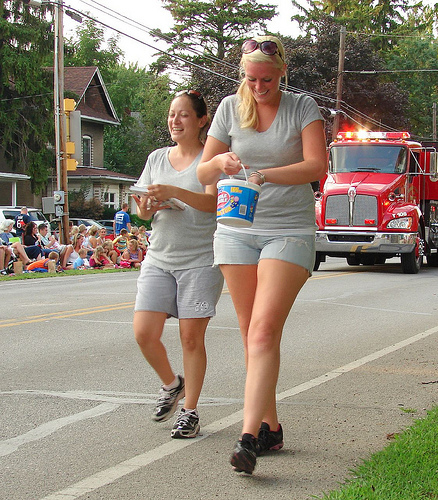<image>
Can you confirm if the woman is behind the woman? No. The woman is not behind the woman. From this viewpoint, the woman appears to be positioned elsewhere in the scene. 